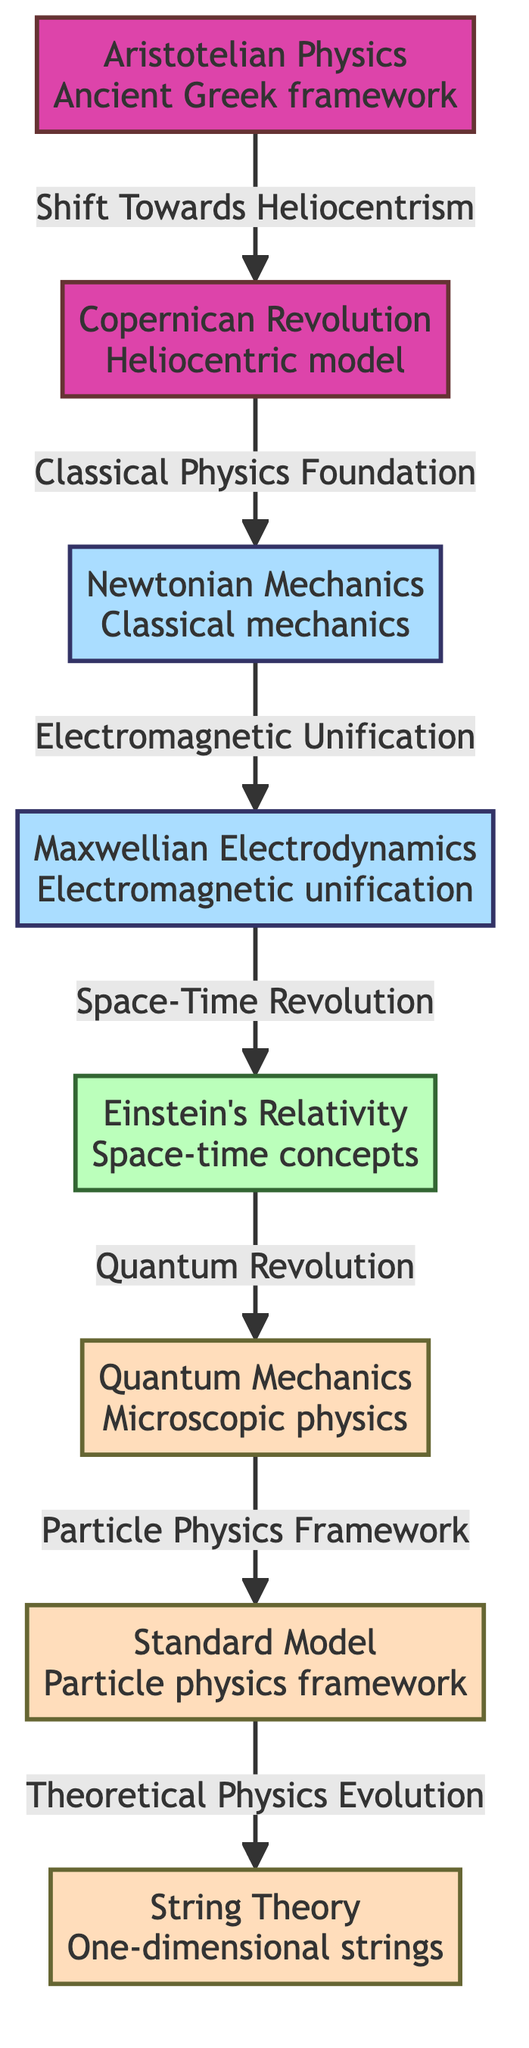What is the first paradigm in the diagram? The diagram begins with "Aristotelian Physics," which is the first node listed.
Answer: Aristotelian Physics How many paradigms are represented in the diagram? There are a total of seven paradigms from "Aristotelian Physics" to "String Theory," which are each represented as nodes.
Answer: 7 Which paradigm follows "Newtonian Mechanics"? The arrow pointing to the next node indicates that "Maxwellian Electrodynamics" follows "Newtonian Mechanics."
Answer: Maxwellian Electrodynamics What relationship is indicated between "Einstein's Relativity" and "Quantum Mechanics"? The diagram shows that "Einstein's Relativity" connects to "Quantum Mechanics" through the label "Quantum Revolution," indicating a significant conceptual shift.
Answer: Quantum Revolution Which paradigm serves as a bridge between classical mechanics and modern physics? "Maxwellian Electrodynamics" acts as a crucial bridge, as it connects "Newtonian Mechanics" to "Einstein's Relativity."
Answer: Maxwellian Electrodynamics Which paradigm is at the end of the sequence in the diagram? The final node in the flow is "String Theory," indicating that it is the current point in the evolution of scientific paradigms represented in this diagram.
Answer: String Theory How does "Quantum Mechanics" relate to "Standard Model"? The connection between "Quantum Mechanics" and "Standard Model" is explored through the label "Particle Physics Framework," indicating its role in particle physics.
Answer: Particle Physics Framework What shift does "Copernican Revolution" illustrate in the context of the evolution of paradigms? The "Copernican Revolution" illustrates a shift towards heliocentrism, moving away from the geocentric view and establishing a foundational change in scientific thought.
Answer: Shift Towards Heliocentrism What major transformation in physics is associated with "Einstein's Relativity"? The transition from classical views to conceptualizations that incorporate space-time is associated with "Einstein's Relativity."
Answer: Space-Time Revolution 